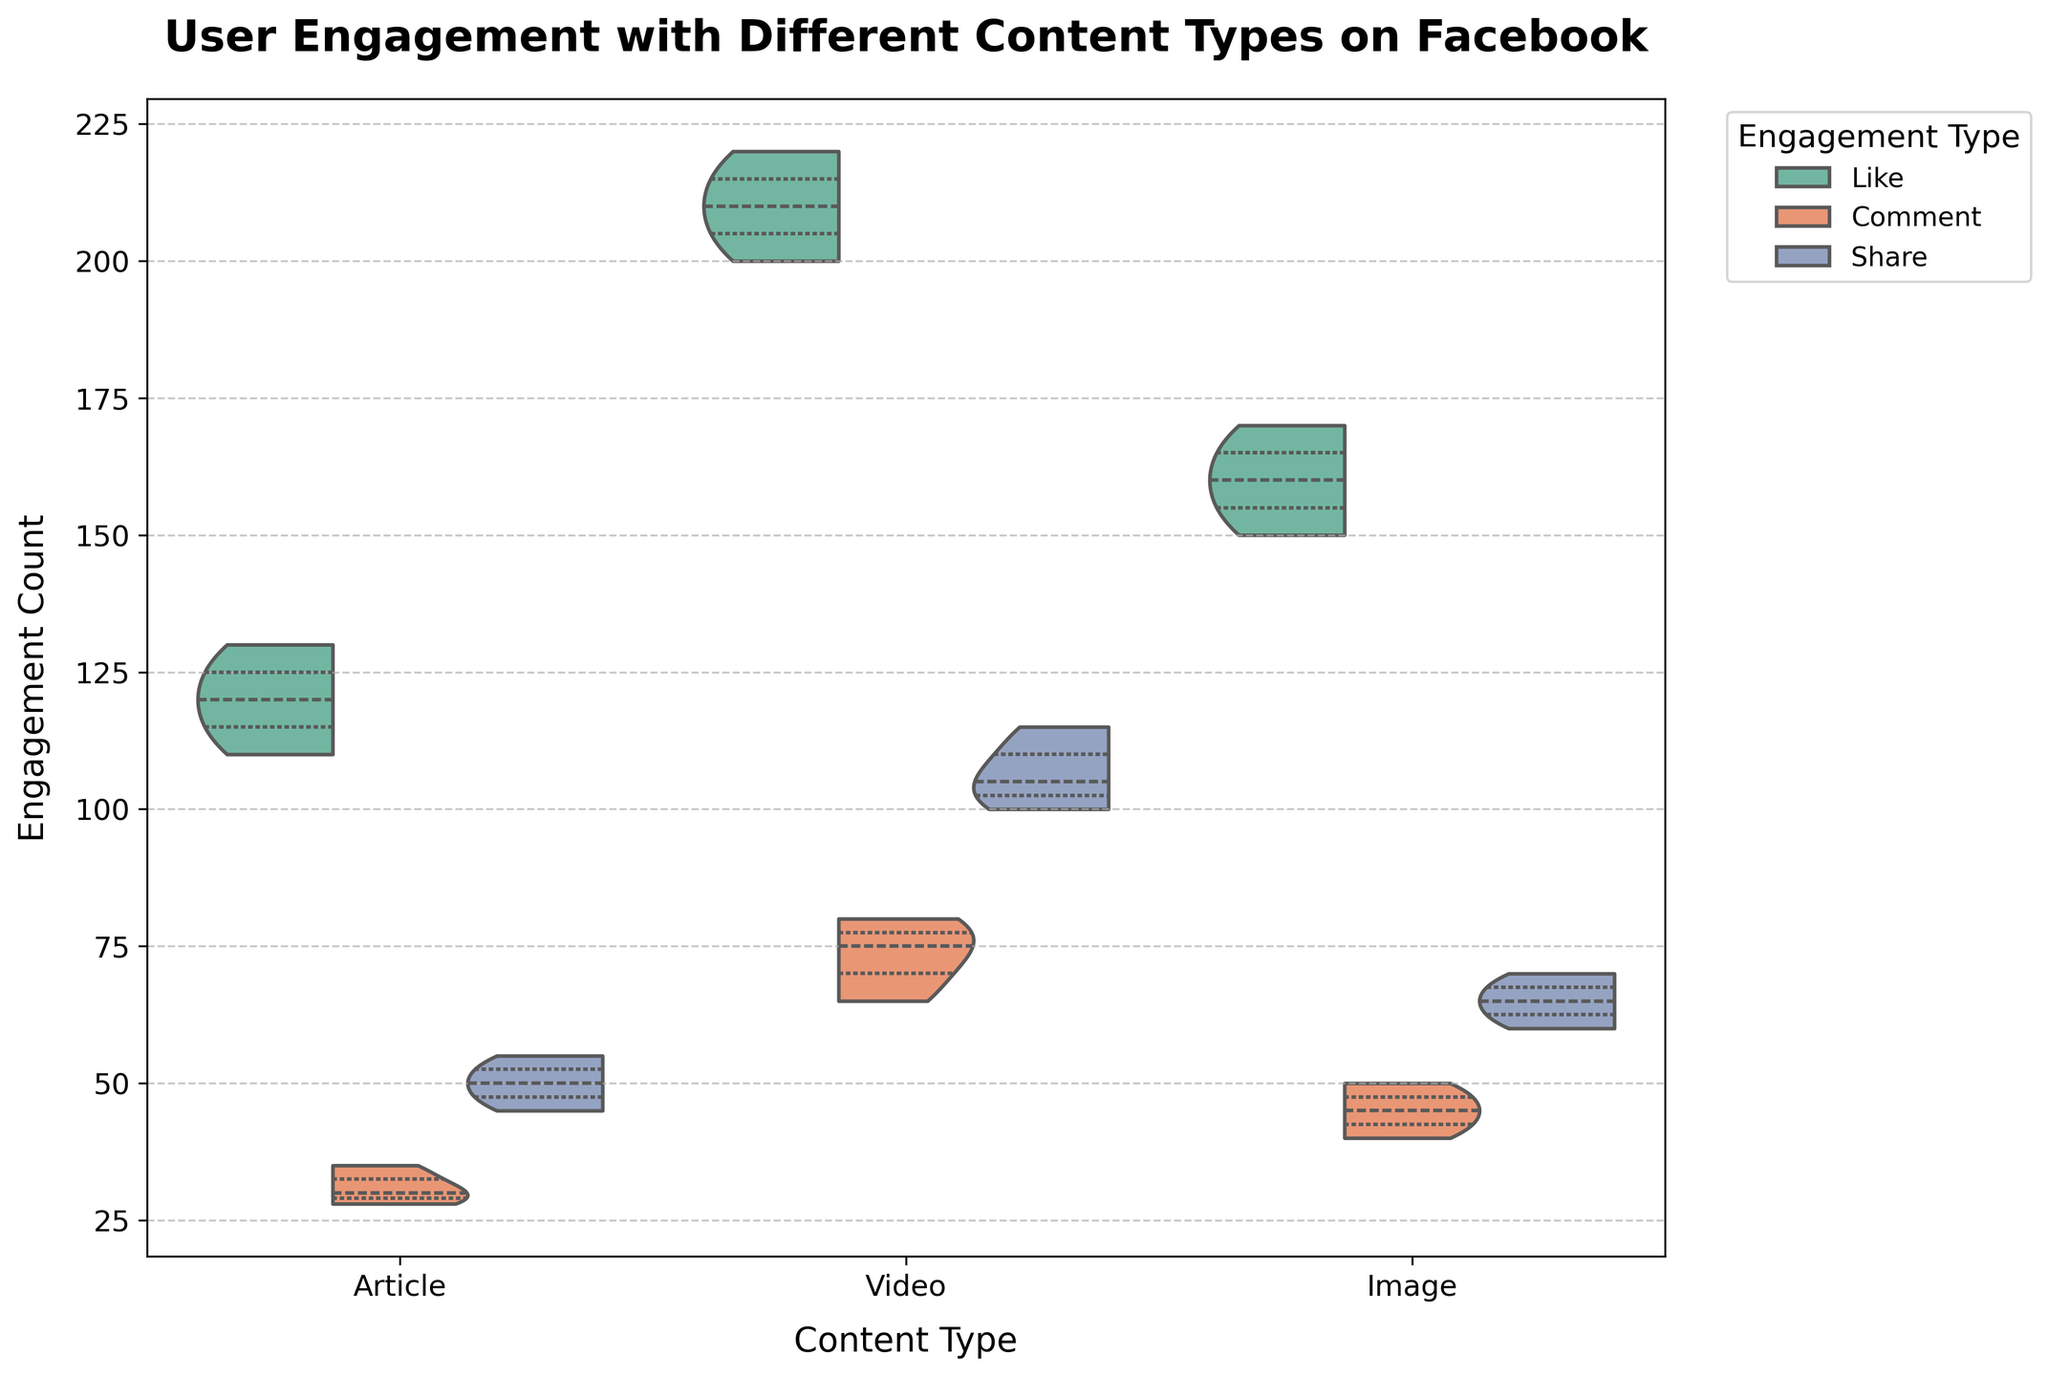What's the title of the plot? The title of the plot is displayed at the top of the figure and provides a brief description of what the plot represents. From the given data and code, the title is "User Engagement with Different Content Types on Facebook".
Answer: User Engagement with Different Content Types on Facebook What are the different types of content shown in the plot? The different types of content can be identified by looking at the categories along the x-axis of the plot. The plot shows three types of content: articles, videos, and images.
Answer: Articles, Videos, Images Which content type has the highest overall engagement count, and for which engagement type is this true? To determine the highest overall engagement count, we need to look at the peaks of the violins for each content type and engagement type. Videos have the tallest violins for 'Like', indicating the highest overall engagement count.
Answer: Videos, Like How do the engagement counts for 'Comments' on articles compare to those on images? To answer this, we compare the height and width of the violins for 'Comments' on both articles and images. The violins for comments on articles are narrower and have a slightly lower height compared to those on images, which have wider and taller violins.
Answer: Comments on images are generally higher than on articles What's the approximate range of engagement counts for 'Shares' on videos? The approximate range for 'Shares' on videos can be identified by looking at the top and bottom of the split violin for video shares. The data ranges approximately from 100 to 115.
Answer: 100 to 115 Which engagement type appears to have the smallest range of counts across all content types? By examining the spread of the violins horizontally, we can see that comments for all content types have the narrowest range of engagement counts, indicating smaller variability.
Answer: Comments Are 'Likes' uniformly distributed across all content types? To assess uniform distribution, we observe the shape of the violins for 'Likes' on each content type. The violins for 'Likes' on videos are much taller and wider compared to those for articles and images, indicating a higher concentration of likes for videos.
Answer: No, 'Likes' are not uniformly distributed; they are more concentrated on videos Which content type has the most balanced engagement across likes, comments, and shares? To determine balance, we look for similar widths and heights of the violins across all engagement types for each content type. Articles have more similar distributions across likes, comments, and shares, suggesting a more balanced engagement.
Answer: Articles Is the median engagement count for 'Likes' higher on videos or on images? By observing the inner quartile lines within the violins, we can note that the median line (middle quartile) for 'Likes' is higher on videos than on images.
Answer: Higher on videos What color palette is used for the engagement types, and which hue represents 'Shares'? The plot uses the 'Set2' color palette, and based on the legend provided, 'Shares' are represented by the specific hue assigned to that engagement type within this palette.
Answer: 'Set2' palette, the specific hue for 'Shares' as indicated in the legend 